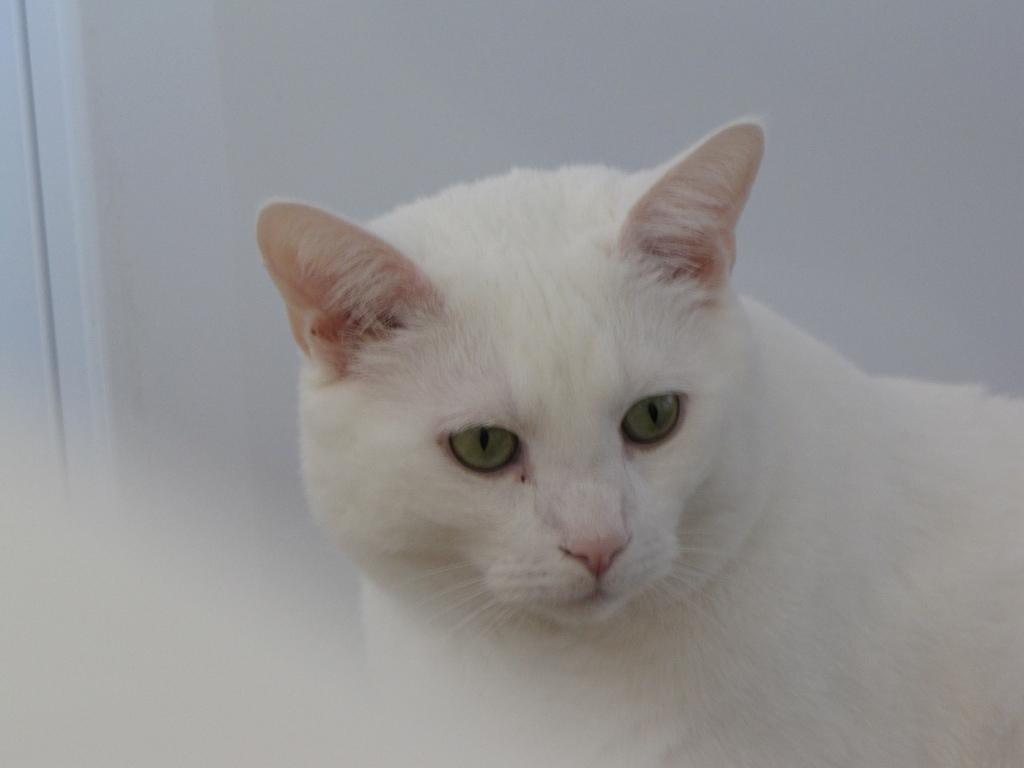What type of animal is in the image? There is a cat in the image. How is the cat depicted in the image? The cat is truncated. What color is the background of the image? The background of the image is white. How many cattle are present in the image? There are no cattle present in the image; it features a cat. What is the interest rate on the account shown in the image? There is no account or mention of interest rates in the image. 